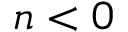<formula> <loc_0><loc_0><loc_500><loc_500>n < 0</formula> 